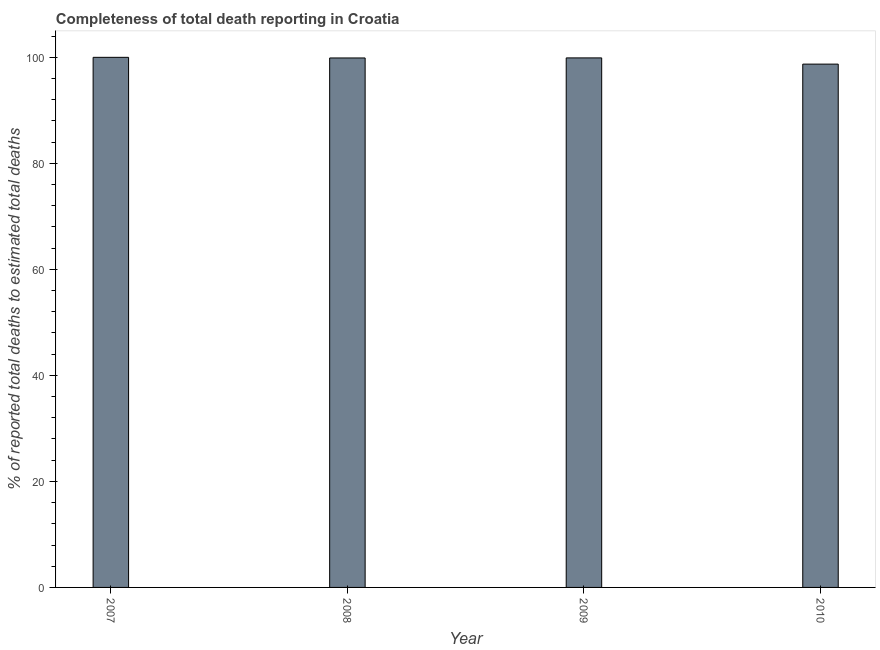Does the graph contain any zero values?
Your answer should be very brief. No. What is the title of the graph?
Offer a terse response. Completeness of total death reporting in Croatia. What is the label or title of the X-axis?
Offer a terse response. Year. What is the label or title of the Y-axis?
Provide a succinct answer. % of reported total deaths to estimated total deaths. What is the completeness of total death reports in 2010?
Offer a terse response. 98.72. Across all years, what is the minimum completeness of total death reports?
Make the answer very short. 98.72. In which year was the completeness of total death reports minimum?
Provide a short and direct response. 2010. What is the sum of the completeness of total death reports?
Ensure brevity in your answer.  398.49. What is the difference between the completeness of total death reports in 2007 and 2010?
Keep it short and to the point. 1.28. What is the average completeness of total death reports per year?
Offer a terse response. 99.62. What is the median completeness of total death reports?
Keep it short and to the point. 99.89. In how many years, is the completeness of total death reports greater than 68 %?
Make the answer very short. 4. Do a majority of the years between 2009 and 2010 (inclusive) have completeness of total death reports greater than 56 %?
Make the answer very short. Yes. What is the ratio of the completeness of total death reports in 2007 to that in 2010?
Give a very brief answer. 1.01. Is the completeness of total death reports in 2007 less than that in 2010?
Give a very brief answer. No. Is the difference between the completeness of total death reports in 2007 and 2009 greater than the difference between any two years?
Ensure brevity in your answer.  No. What is the difference between the highest and the second highest completeness of total death reports?
Provide a succinct answer. 0.11. What is the difference between the highest and the lowest completeness of total death reports?
Make the answer very short. 1.28. Are all the bars in the graph horizontal?
Provide a short and direct response. No. How many years are there in the graph?
Your response must be concise. 4. What is the % of reported total deaths to estimated total deaths in 2008?
Ensure brevity in your answer.  99.88. What is the % of reported total deaths to estimated total deaths in 2009?
Provide a succinct answer. 99.89. What is the % of reported total deaths to estimated total deaths in 2010?
Your answer should be very brief. 98.72. What is the difference between the % of reported total deaths to estimated total deaths in 2007 and 2008?
Provide a short and direct response. 0.12. What is the difference between the % of reported total deaths to estimated total deaths in 2007 and 2009?
Offer a terse response. 0.11. What is the difference between the % of reported total deaths to estimated total deaths in 2007 and 2010?
Offer a terse response. 1.28. What is the difference between the % of reported total deaths to estimated total deaths in 2008 and 2009?
Provide a short and direct response. -0.01. What is the difference between the % of reported total deaths to estimated total deaths in 2008 and 2010?
Your response must be concise. 1.16. What is the difference between the % of reported total deaths to estimated total deaths in 2009 and 2010?
Offer a very short reply. 1.17. What is the ratio of the % of reported total deaths to estimated total deaths in 2007 to that in 2010?
Provide a short and direct response. 1.01. What is the ratio of the % of reported total deaths to estimated total deaths in 2008 to that in 2009?
Make the answer very short. 1. What is the ratio of the % of reported total deaths to estimated total deaths in 2008 to that in 2010?
Give a very brief answer. 1.01. 